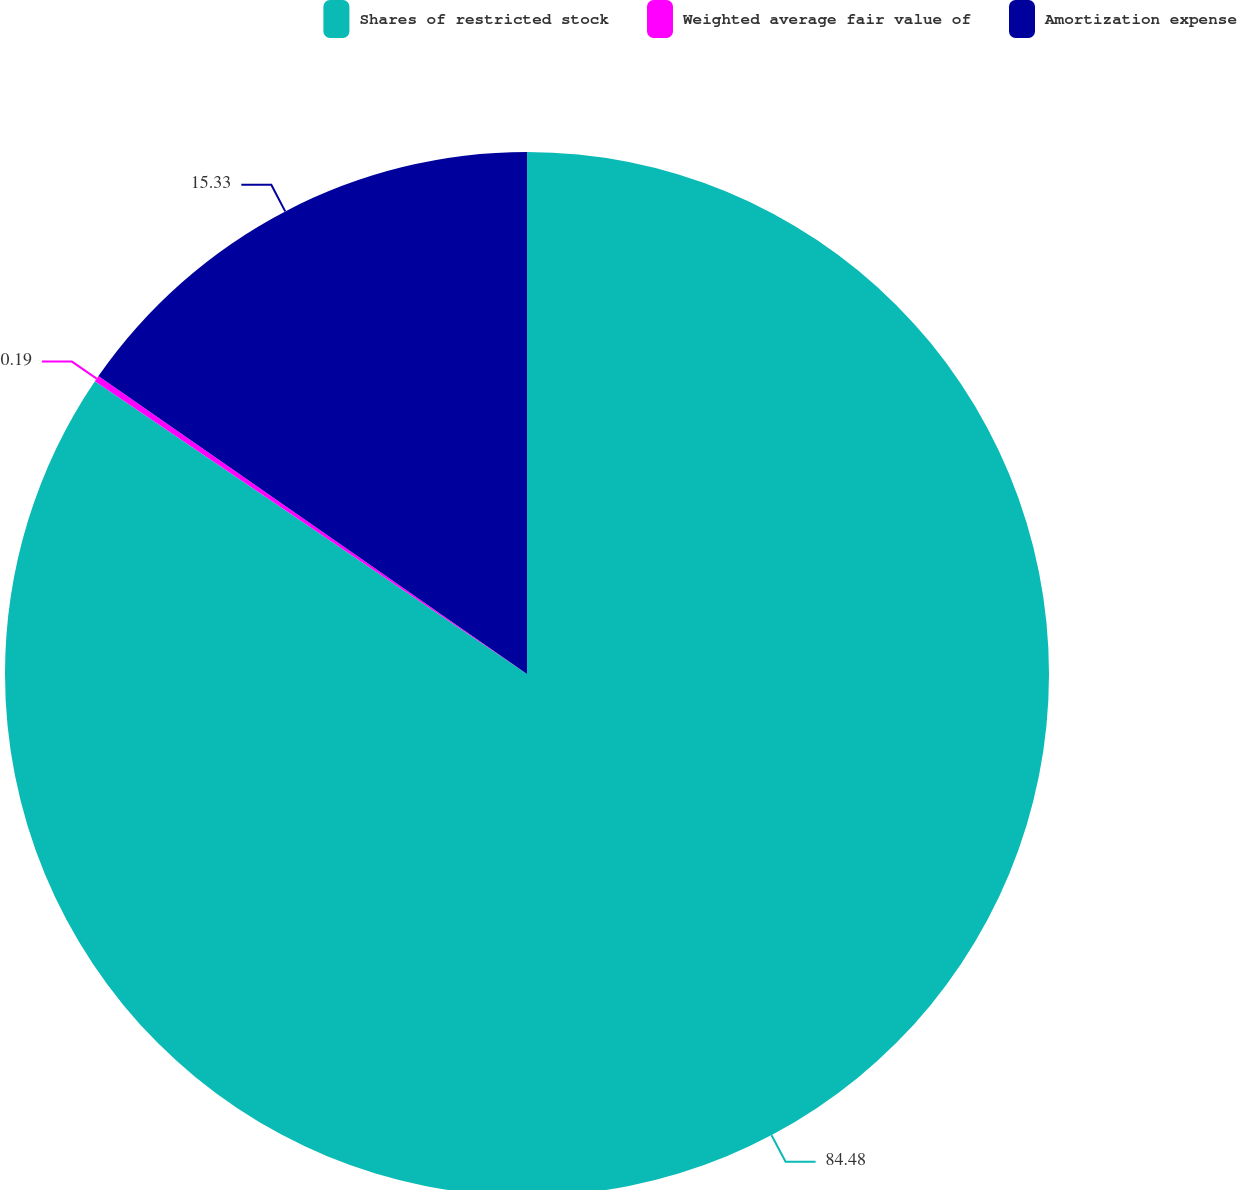<chart> <loc_0><loc_0><loc_500><loc_500><pie_chart><fcel>Shares of restricted stock<fcel>Weighted average fair value of<fcel>Amortization expense<nl><fcel>84.48%<fcel>0.19%<fcel>15.33%<nl></chart> 